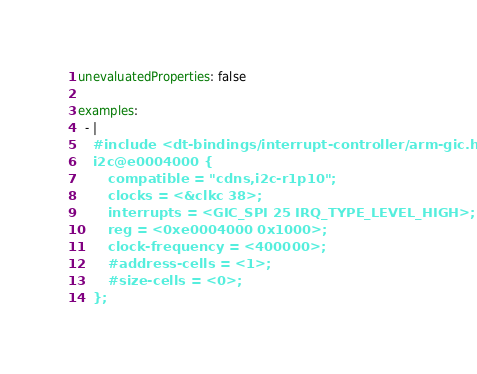<code> <loc_0><loc_0><loc_500><loc_500><_YAML_>unevaluatedProperties: false

examples:
  - |
    #include <dt-bindings/interrupt-controller/arm-gic.h>
    i2c@e0004000 {
        compatible = "cdns,i2c-r1p10";
        clocks = <&clkc 38>;
        interrupts = <GIC_SPI 25 IRQ_TYPE_LEVEL_HIGH>;
        reg = <0xe0004000 0x1000>;
        clock-frequency = <400000>;
        #address-cells = <1>;
        #size-cells = <0>;
    };
</code> 